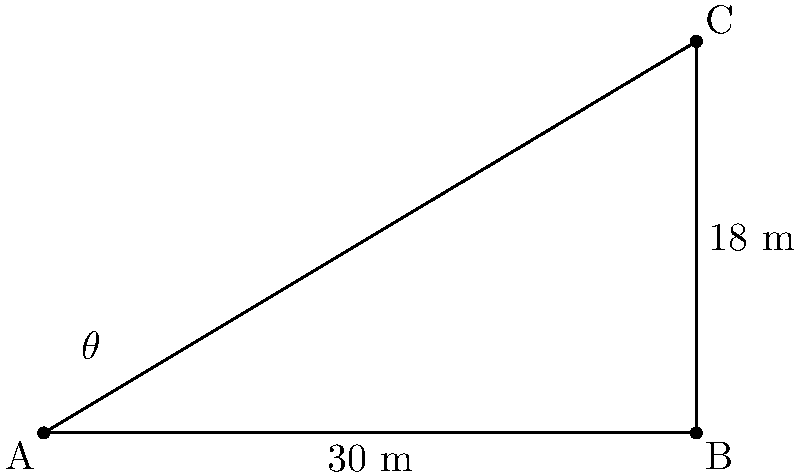As a marketing specialist for Sac State, you're tasked with optimizing billboard visibility along a busy highway. A potential billboard location is 18 meters above the ground and 30 meters from the observation point. What angle $\theta$ should the billboard be tilted from the vertical to maximize visibility for drivers passing by? Let's approach this step-by-step:

1) We can model this scenario as a right triangle, where:
   - The vertical side (adjacent to $\theta$) is 18 m (height of the billboard)
   - The horizontal side (opposite to $\theta$) is 30 m (distance from observation point)

2) To maximize visibility, the billboard should be perpendicular to the line of sight from the observation point to the top of the billboard.

3) This means we need to find the angle $\theta$ that makes the billboard perpendicular to the hypotenuse of our right triangle.

4) In a right triangle, the angle between the hypotenuse and one side is complementary to the angle between the other side and the hypotenuse.

5) So, if we find the angle the hypotenuse makes with the ground, $\theta$ will be its complement (90° - that angle).

6) We can find this angle using the arctangent function:

   $$\tan^{-1}(\frac{\text{opposite}}{\text{adjacent}}) = \tan^{-1}(\frac{18}{30}) = \tan^{-1}(0.6)$$

7) Using a calculator or trigonometric tables:

   $$\tan^{-1}(0.6) \approx 30.96°$$

8) Therefore, $\theta = 90° - 30.96° = 59.04°$

This angle will position the billboard perpendicular to the line of sight, maximizing its visibility.
Answer: $59.04°$ from vertical 